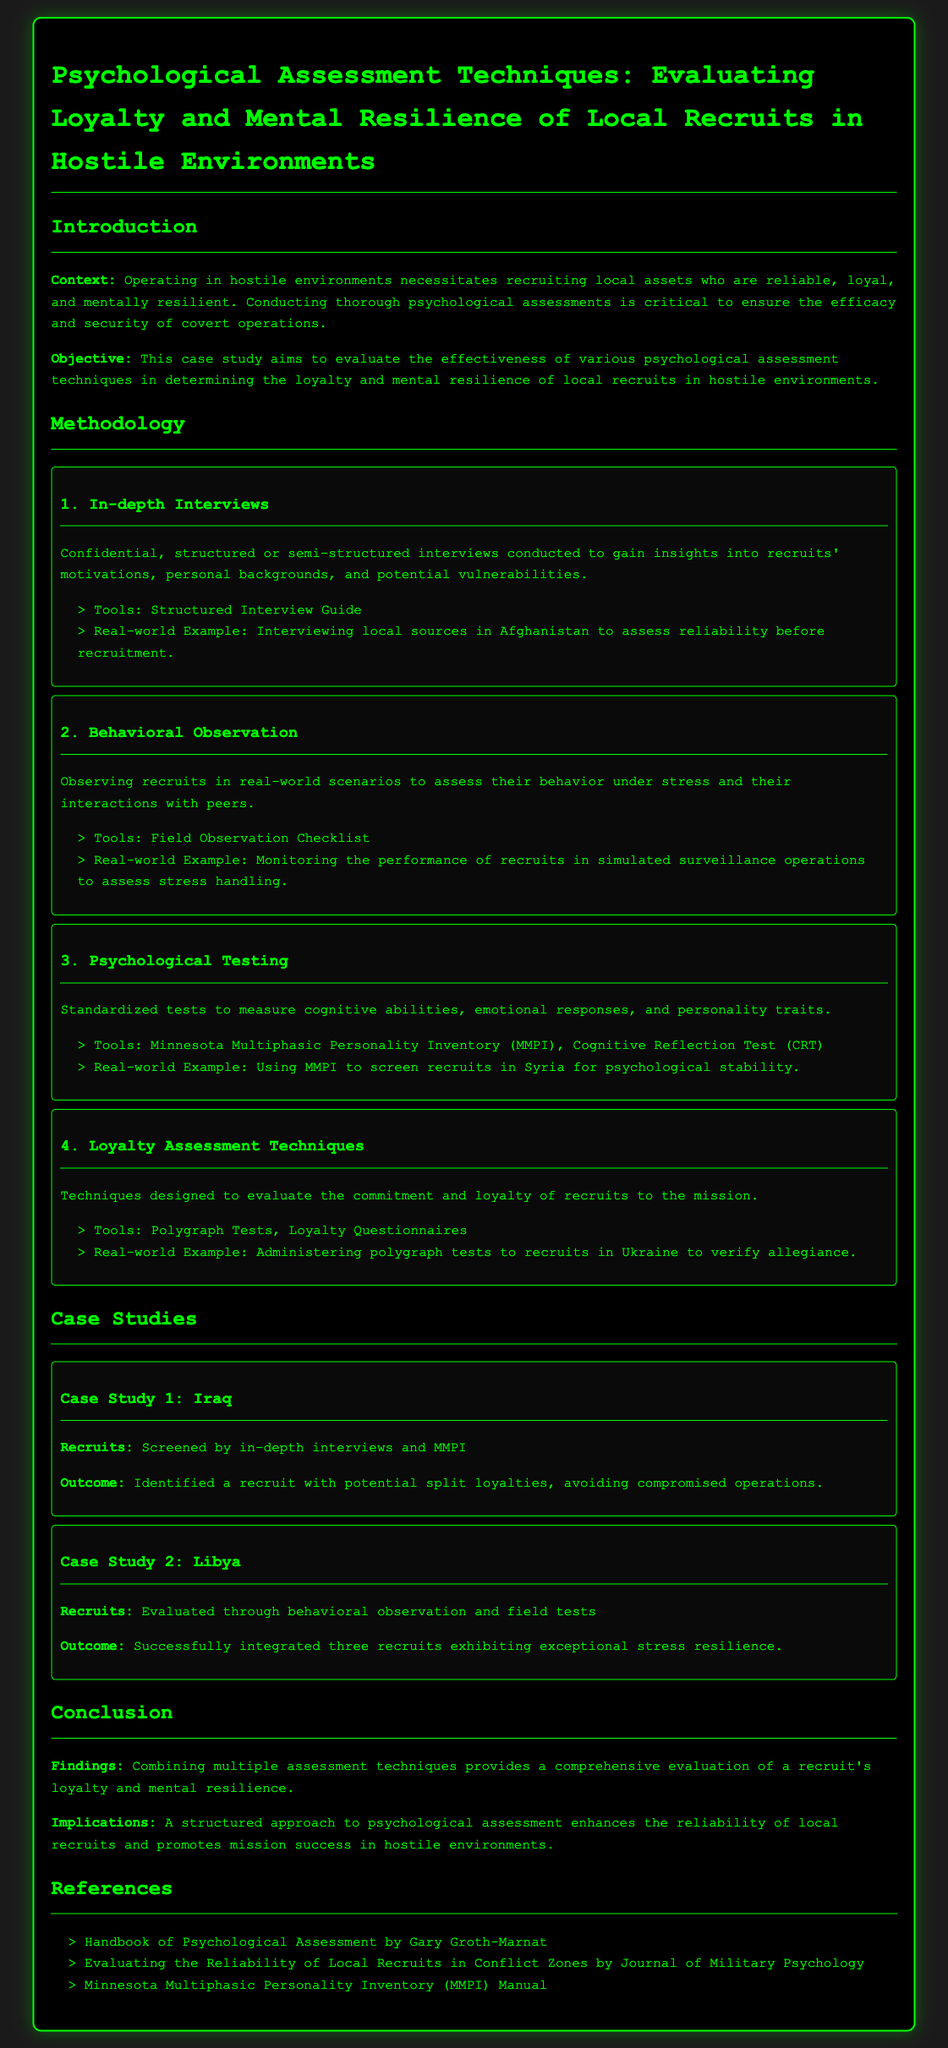what is the title of the case study? The title of the case study is directly stated at the beginning in the header.
Answer: Psychological Assessment Techniques: Evaluating Loyalty and Mental Resilience of Local Recruits in Hostile Environments what methodological tool is used for in-depth interviews? The document specifies that a structured interview guide is the tool used for in-depth interviews.
Answer: Structured Interview Guide which psychological test is mentioned for screening recruits in Syria? The case study lists the Minnesota Multiphasic Personality Inventory as a psychological test used in Syria.
Answer: Minnesota Multiphasic Personality Inventory (MMPI) how many case studies are presented in the document? The document explicitly lists two case studies in the relevant section.
Answer: 2 what was the outcome of the recruits screened in Iraq? The outcome reported in the case study indicates the identification of a recruit with potential split loyalties.
Answer: Identified a recruit with potential split loyalties which observation technique was utilized in the Libya case study? The document indicates that behavioral observation was the primary technique employed in Libya.
Answer: Behavioral observation what is one implication of the findings mentioned in the conclusion? The document states that a structured approach enhances the reliability of local recruits.
Answer: Enhances reliability of local recruits name a reference listed in the document. The conclusion section includes several references that can be directly quoted.
Answer: Handbook of Psychological Assessment by Gary Groth-Marnat which environment is highlighted as hostile in the context of local recruit evaluation? The introduction mentions hostile environments as the context where local assets are recruited.
Answer: Hostile environments 